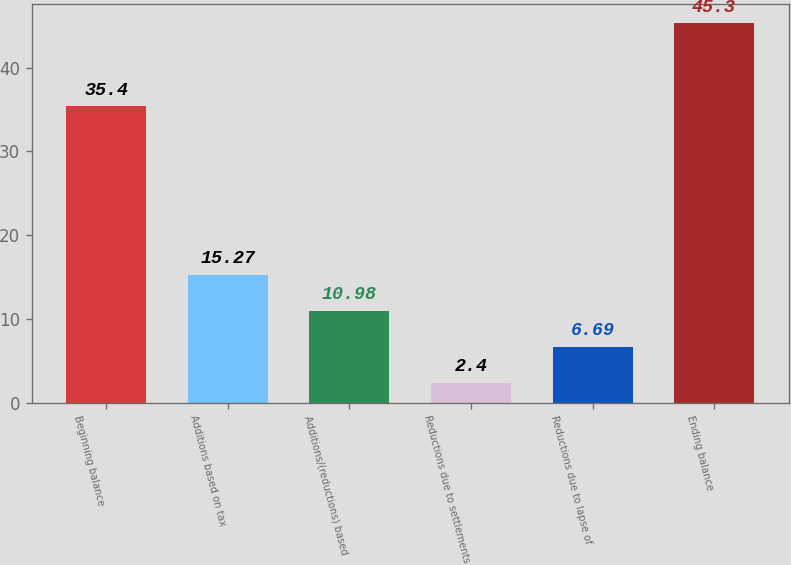<chart> <loc_0><loc_0><loc_500><loc_500><bar_chart><fcel>Beginning balance<fcel>Additions based on tax<fcel>Additions/(reductions) based<fcel>Reductions due to settlements<fcel>Reductions due to lapse of<fcel>Ending balance<nl><fcel>35.4<fcel>15.27<fcel>10.98<fcel>2.4<fcel>6.69<fcel>45.3<nl></chart> 